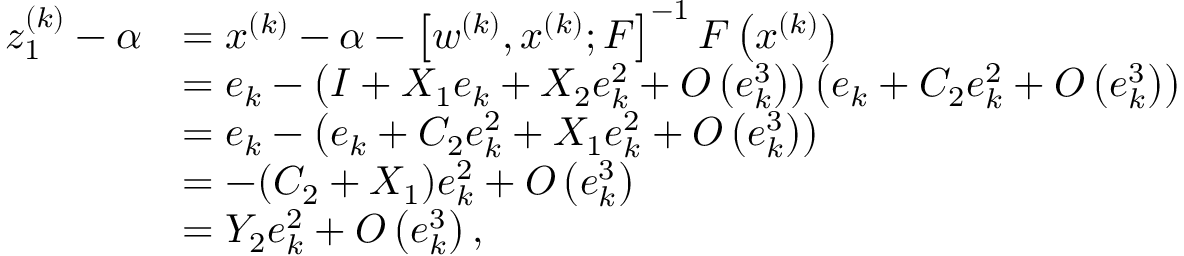<formula> <loc_0><loc_0><loc_500><loc_500>\begin{array} { r l } { z _ { 1 } ^ { ( k ) } - \alpha } & { = x ^ { ( k ) } - \alpha - \left [ w ^ { ( k ) } , x ^ { ( k ) } ; F \right ] ^ { - 1 } F \left ( x ^ { ( k ) } \right ) } \\ & { = e _ { k } - \left ( I + X _ { 1 } e _ { k } + X _ { 2 } e _ { k } ^ { 2 } + O \left ( e _ { k } ^ { 3 } \right ) \right ) \left ( e _ { k } + C _ { 2 } e _ { k } ^ { 2 } + O \left ( e _ { k } ^ { 3 } \right ) \right ) } \\ & { = e _ { k } - \left ( e _ { k } + C _ { 2 } e _ { k } ^ { 2 } + X _ { 1 } e _ { k } ^ { 2 } + O \left ( e _ { k } ^ { 3 } \right ) \right ) } \\ & { = - ( C _ { 2 } + X _ { 1 } ) e _ { k } ^ { 2 } + O \left ( e _ { k } ^ { 3 } \right ) } \\ & { = Y _ { 2 } e _ { k } ^ { 2 } + O \left ( e _ { k } ^ { 3 } \right ) , } \end{array}</formula> 